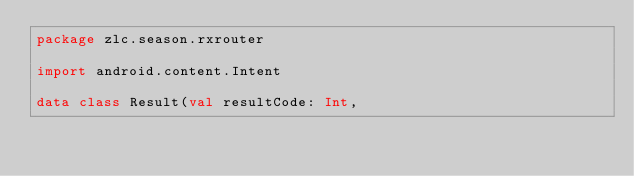Convert code to text. <code><loc_0><loc_0><loc_500><loc_500><_Kotlin_>package zlc.season.rxrouter

import android.content.Intent

data class Result(val resultCode: Int,</code> 